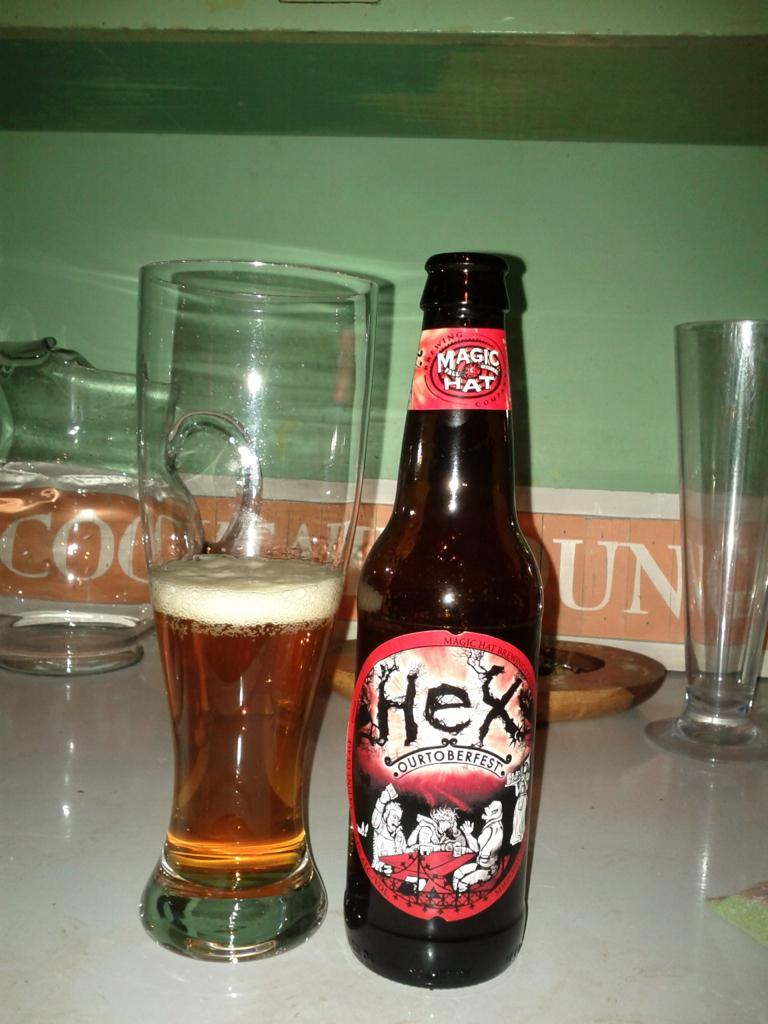<image>
Share a concise interpretation of the image provided. a bottle and glass of Magic Hat Hexes beer 